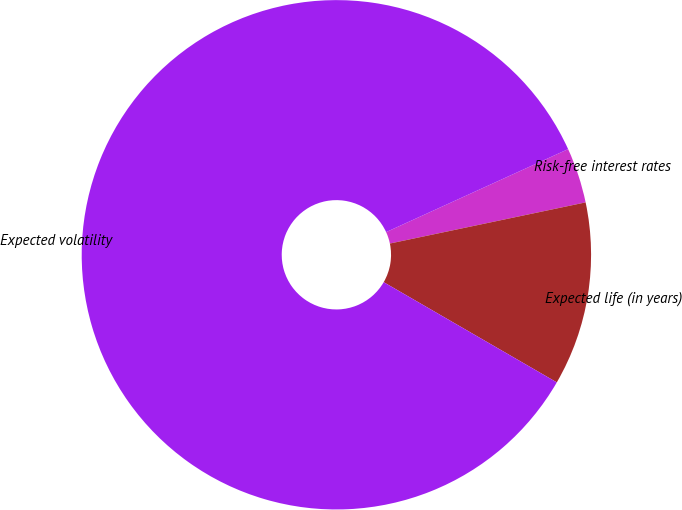Convert chart. <chart><loc_0><loc_0><loc_500><loc_500><pie_chart><fcel>Risk-free interest rates<fcel>Expected life (in years)<fcel>Expected volatility<nl><fcel>3.51%<fcel>11.65%<fcel>84.84%<nl></chart> 